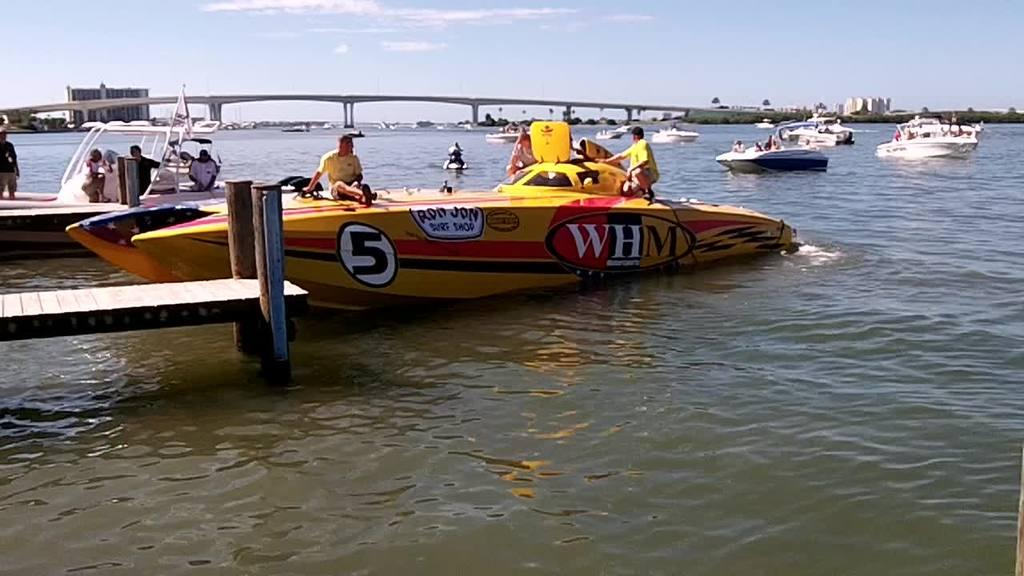What is happening on the water in the image? There are boats on water in the image, with people on the boats. What can be seen on the boats? There is a flag and a platform on the boats. What is visible in the background of the image? There is a bridge, buildings, trees, and the sky visible in the image. What is the condition of the sky in the image? The sky is visible in the background, with clouds present. What type of sound can be heard coming from the seashore in the image? There is no seashore present in the image, as it features boats on water with a bridge, buildings, trees, and the sky visible in the background. What angle is the image taken from? The angle from which the image is taken cannot be determined from the image itself, as it only provides a visual representation of the scene. 